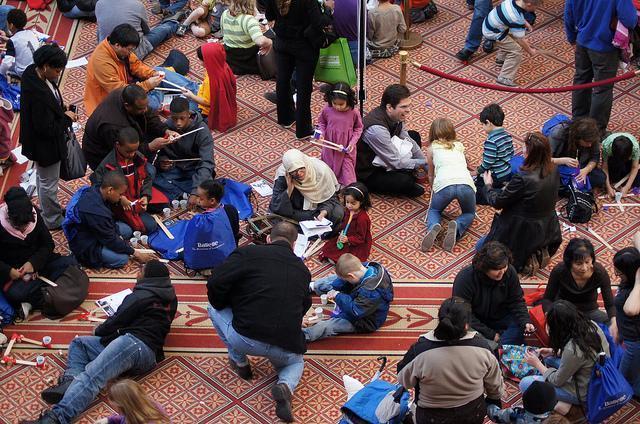How many backpacks are there?
Give a very brief answer. 2. How many people are in the photo?
Give a very brief answer. 13. How many of the frisbees are in the air?
Give a very brief answer. 0. 